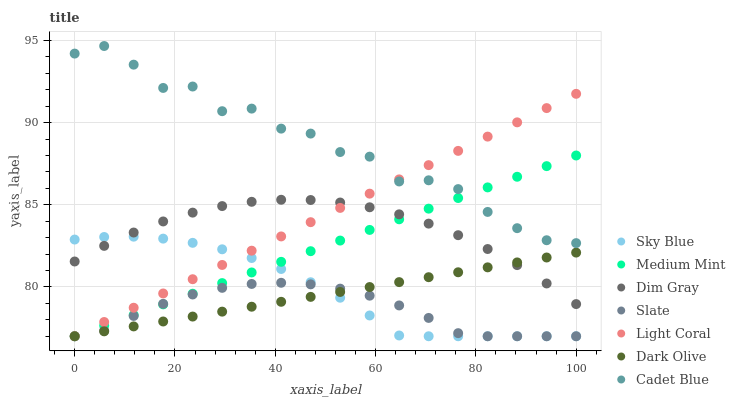Does Slate have the minimum area under the curve?
Answer yes or no. Yes. Does Cadet Blue have the maximum area under the curve?
Answer yes or no. Yes. Does Dim Gray have the minimum area under the curve?
Answer yes or no. No. Does Dim Gray have the maximum area under the curve?
Answer yes or no. No. Is Medium Mint the smoothest?
Answer yes or no. Yes. Is Cadet Blue the roughest?
Answer yes or no. Yes. Is Dim Gray the smoothest?
Answer yes or no. No. Is Dim Gray the roughest?
Answer yes or no. No. Does Medium Mint have the lowest value?
Answer yes or no. Yes. Does Dim Gray have the lowest value?
Answer yes or no. No. Does Cadet Blue have the highest value?
Answer yes or no. Yes. Does Dim Gray have the highest value?
Answer yes or no. No. Is Sky Blue less than Cadet Blue?
Answer yes or no. Yes. Is Cadet Blue greater than Sky Blue?
Answer yes or no. Yes. Does Light Coral intersect Dim Gray?
Answer yes or no. Yes. Is Light Coral less than Dim Gray?
Answer yes or no. No. Is Light Coral greater than Dim Gray?
Answer yes or no. No. Does Sky Blue intersect Cadet Blue?
Answer yes or no. No. 